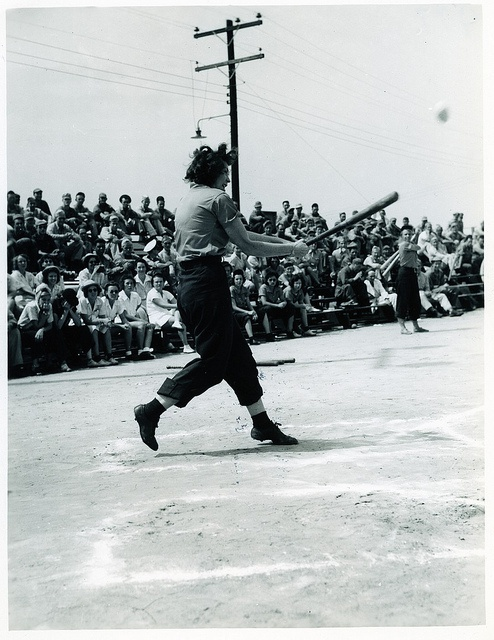Describe the objects in this image and their specific colors. I can see people in white, black, gray, lightgray, and darkgray tones, people in white, black, lightgray, gray, and darkgray tones, people in white, black, gray, darkgray, and lightgray tones, people in white, black, gray, darkgray, and purple tones, and people in white, black, gray, purple, and darkblue tones in this image. 